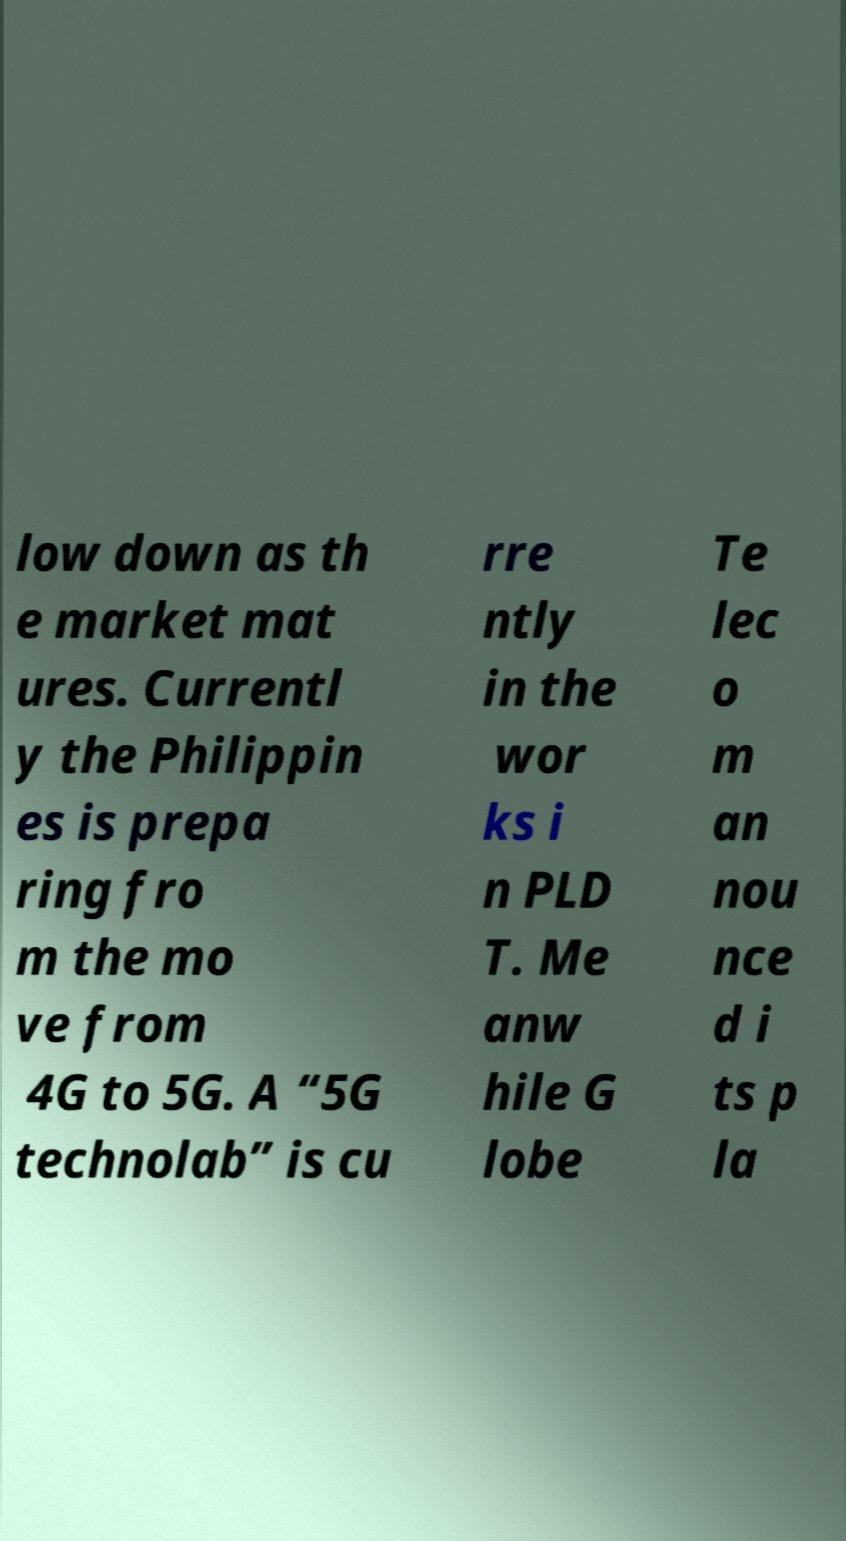There's text embedded in this image that I need extracted. Can you transcribe it verbatim? low down as th e market mat ures. Currentl y the Philippin es is prepa ring fro m the mo ve from 4G to 5G. A “5G technolab” is cu rre ntly in the wor ks i n PLD T. Me anw hile G lobe Te lec o m an nou nce d i ts p la 